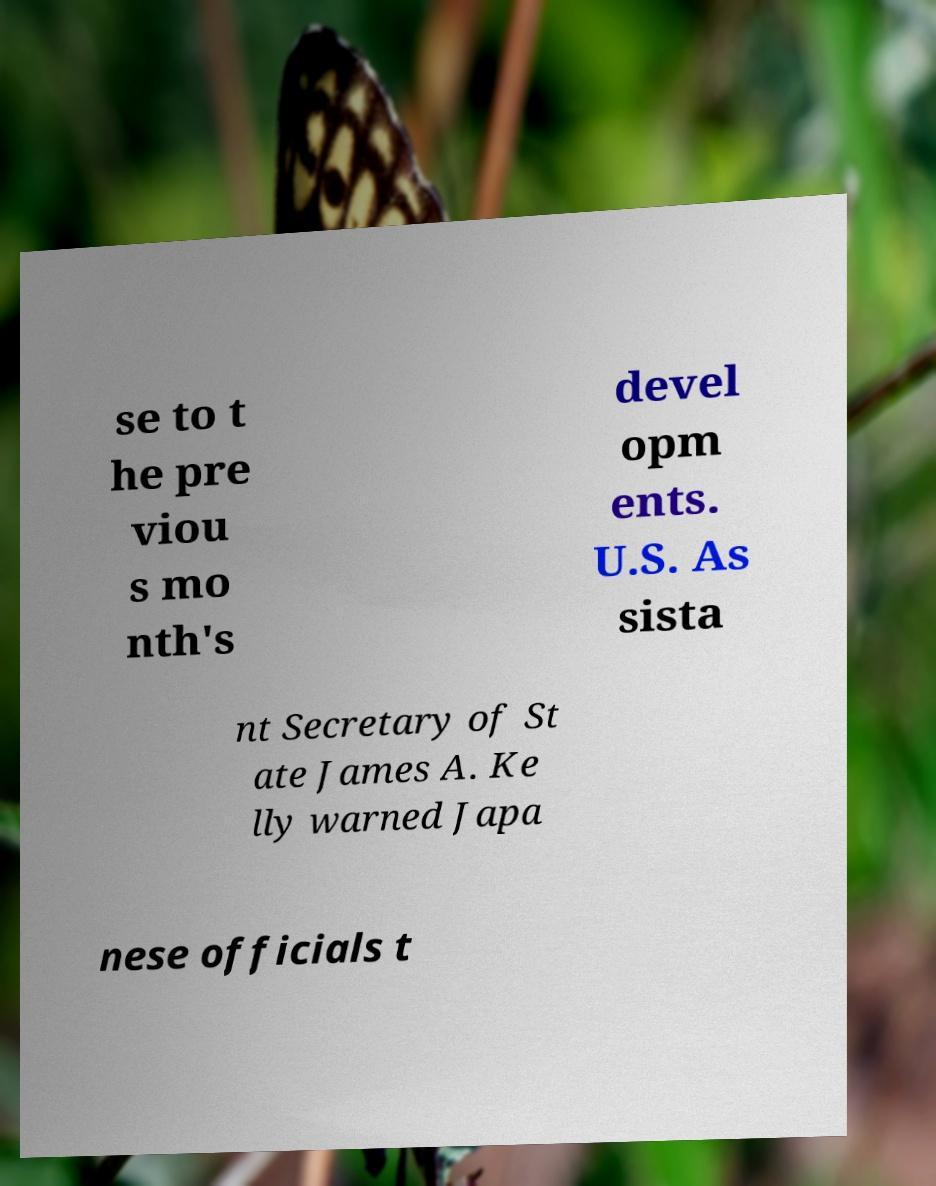Please read and relay the text visible in this image. What does it say? se to t he pre viou s mo nth's devel opm ents. U.S. As sista nt Secretary of St ate James A. Ke lly warned Japa nese officials t 